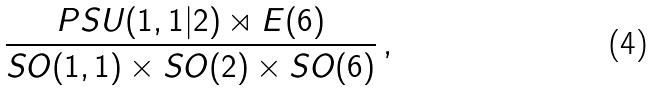<formula> <loc_0><loc_0><loc_500><loc_500>\frac { P S U ( 1 , 1 | 2 ) \rtimes E ( 6 ) } { S O ( 1 , 1 ) \times S O ( 2 ) \times S O ( 6 ) } \, ,</formula> 